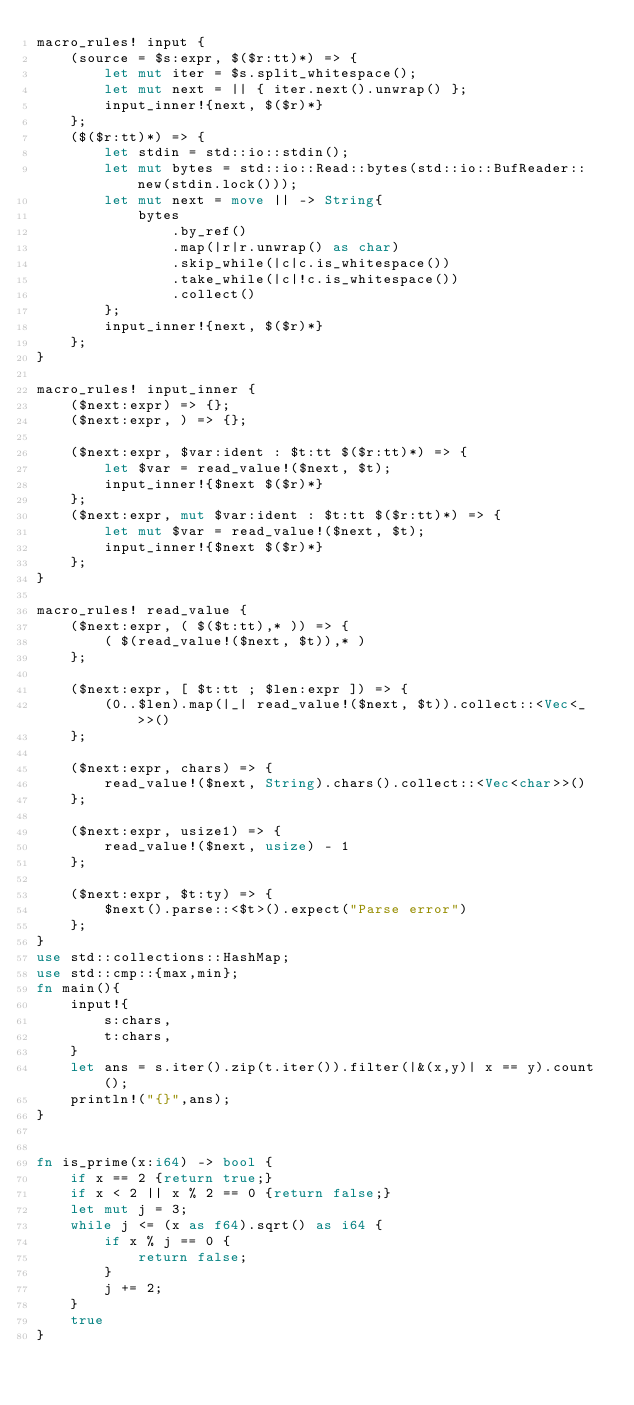Convert code to text. <code><loc_0><loc_0><loc_500><loc_500><_Rust_>macro_rules! input {
    (source = $s:expr, $($r:tt)*) => {
        let mut iter = $s.split_whitespace();
        let mut next = || { iter.next().unwrap() };
        input_inner!{next, $($r)*}
    };
    ($($r:tt)*) => {
        let stdin = std::io::stdin();
        let mut bytes = std::io::Read::bytes(std::io::BufReader::new(stdin.lock()));
        let mut next = move || -> String{
            bytes
                .by_ref()
                .map(|r|r.unwrap() as char)
                .skip_while(|c|c.is_whitespace())
                .take_while(|c|!c.is_whitespace())
                .collect()
        };
        input_inner!{next, $($r)*}
    };
}

macro_rules! input_inner {
    ($next:expr) => {};
    ($next:expr, ) => {};

    ($next:expr, $var:ident : $t:tt $($r:tt)*) => {
        let $var = read_value!($next, $t);
        input_inner!{$next $($r)*}
    };
    ($next:expr, mut $var:ident : $t:tt $($r:tt)*) => {
        let mut $var = read_value!($next, $t);
        input_inner!{$next $($r)*}
    };
}

macro_rules! read_value {
    ($next:expr, ( $($t:tt),* )) => {
        ( $(read_value!($next, $t)),* )
    };

    ($next:expr, [ $t:tt ; $len:expr ]) => {
        (0..$len).map(|_| read_value!($next, $t)).collect::<Vec<_>>()
    };

    ($next:expr, chars) => {
        read_value!($next, String).chars().collect::<Vec<char>>()
    };

    ($next:expr, usize1) => {
        read_value!($next, usize) - 1
    };

    ($next:expr, $t:ty) => {
        $next().parse::<$t>().expect("Parse error")
    };
}
use std::collections::HashMap;
use std::cmp::{max,min};
fn main(){
    input!{
        s:chars,
        t:chars,
    }
    let ans = s.iter().zip(t.iter()).filter(|&(x,y)| x == y).count();
    println!("{}",ans);
}


fn is_prime(x:i64) -> bool {
    if x == 2 {return true;}
    if x < 2 || x % 2 == 0 {return false;}
    let mut j = 3;
    while j <= (x as f64).sqrt() as i64 {
        if x % j == 0 {
            return false;
        }
        j += 2;
    }
    true
}
</code> 